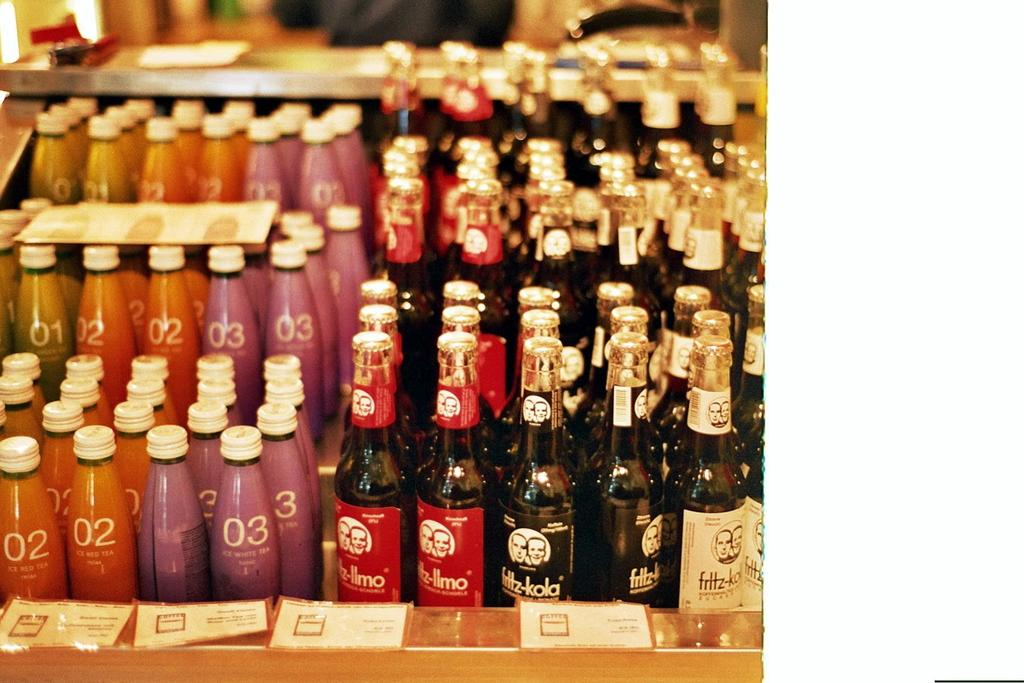<image>
Summarize the visual content of the image. bottles of fritz-kola next to smaller bottles with 02 and 03 on them 